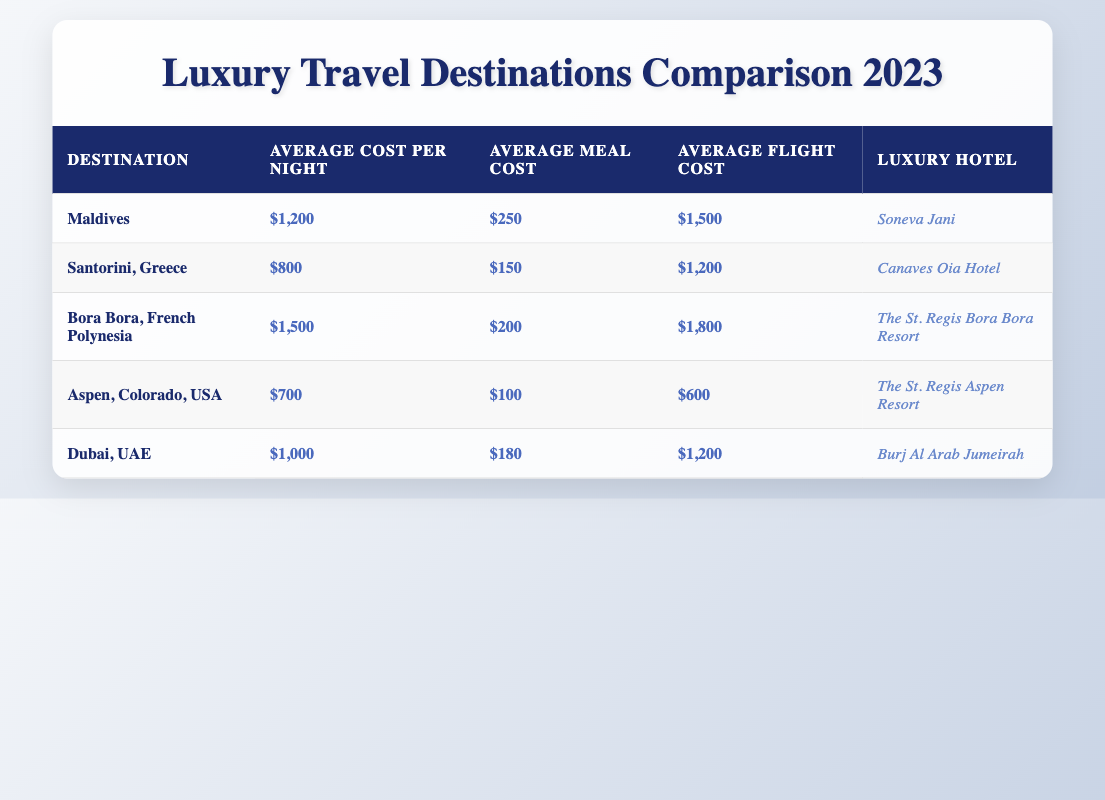What is the average cost per night in Bora Bora? The table shows that the average cost per night in Bora Bora is listed as $1,500.
Answer: $1,500 Which luxury hotel is associated with Dubai? According to the table, the luxury hotel listed for Dubai is Burj Al Arab Jumeirah.
Answer: Burj Al Arab Jumeirah Is the average flight cost to Santorini higher than that to Aspen? The average flight cost to Santorini is $1,200, while the cost to Aspen is $600. Since $1,200 is greater than $600, the statement is true.
Answer: Yes What is the total average cost (per night, meal, and flight) for a trip to the Maldives? To find the total average cost for the Maldives, we sum up the average costs: $1,200 (per night) + $250 (meal) + $1,500 (flight) = $2,950.
Answer: $2,950 Which destination has the highest average meal cost? By comparing the average meal costs from the table, the Maldives has the highest average meal cost of $250, compared to the others.
Answer: Maldives How much more does it cost, on average, to stay per night in Bora Bora compared to Santorini? The average cost per night in Bora Bora is $1,500, and in Santorini it's $800. The difference is $1,500 - $800 = $700.
Answer: $700 Are the average meal costs in Dubai and Aspen both below $200? The average meal cost in Dubai is $180, which is below $200, but in Aspen it is $100, which also makes it below $200. Therefore, both costs are under $200.
Answer: Yes What is the average cost per night across all listed destinations? To calculate the average cost per night for all destinations: ($1,200 + $800 + $1,500 + $700 + $1,000) / 5 = $1,040.
Answer: $1,040 Which location is the cheapest for an average meal cost? By examining the table, the average meal cost is $100 in Aspen, making it the cheapest option.
Answer: Aspen Is the flight cost to Bora Bora the highest among all destinations listed? The flight cost to Bora Bora is $1,800. The costs for the other destinations are lower ($1,200 for Santorini and Dubai, $1,500 for Maldives, $600 for Aspen) indicating that Bora Bora has the highest flight cost.
Answer: Yes 